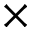Convert formula to latex. <formula><loc_0><loc_0><loc_500><loc_500>\times</formula> 